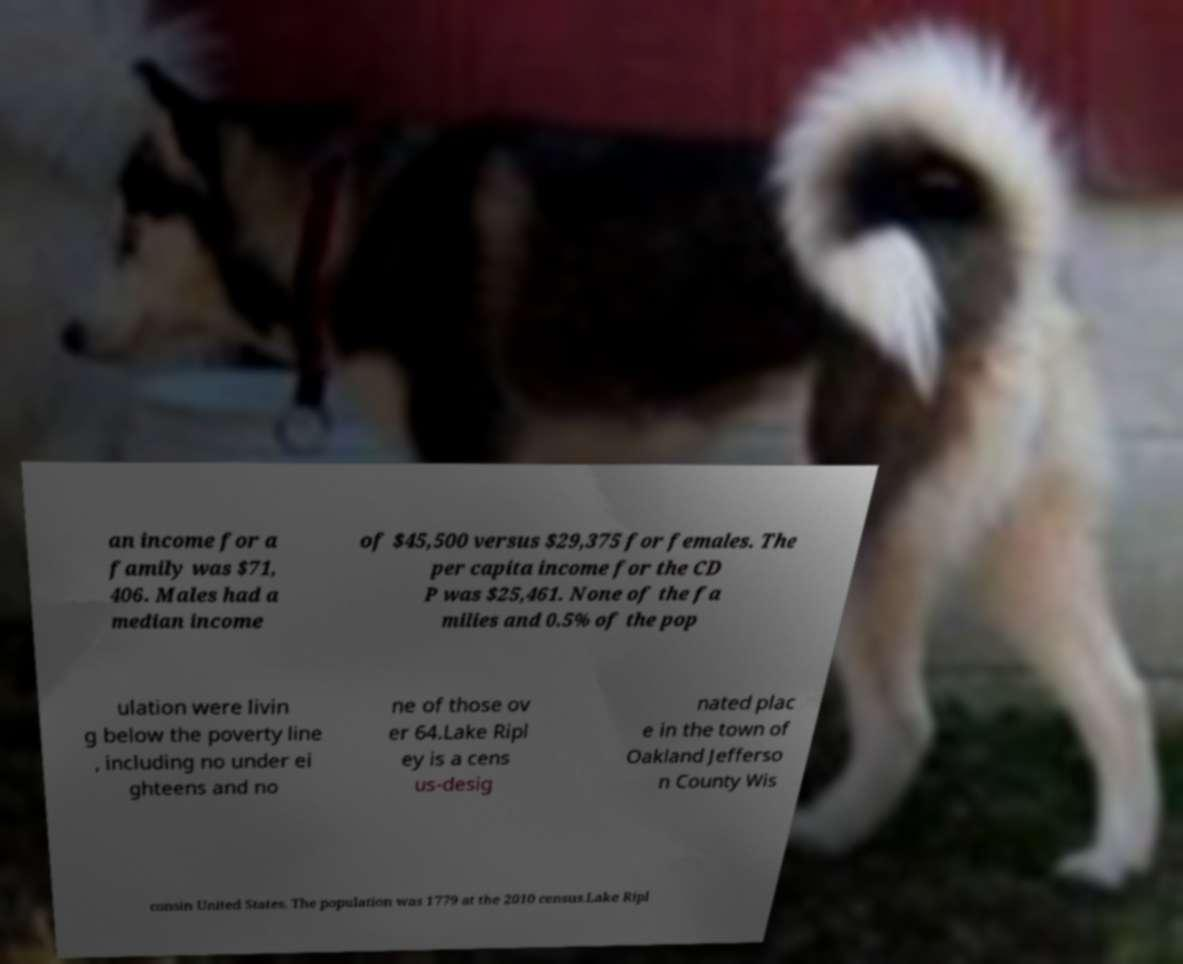What messages or text are displayed in this image? I need them in a readable, typed format. an income for a family was $71, 406. Males had a median income of $45,500 versus $29,375 for females. The per capita income for the CD P was $25,461. None of the fa milies and 0.5% of the pop ulation were livin g below the poverty line , including no under ei ghteens and no ne of those ov er 64.Lake Ripl ey is a cens us-desig nated plac e in the town of Oakland Jefferso n County Wis consin United States. The population was 1779 at the 2010 census.Lake Ripl 